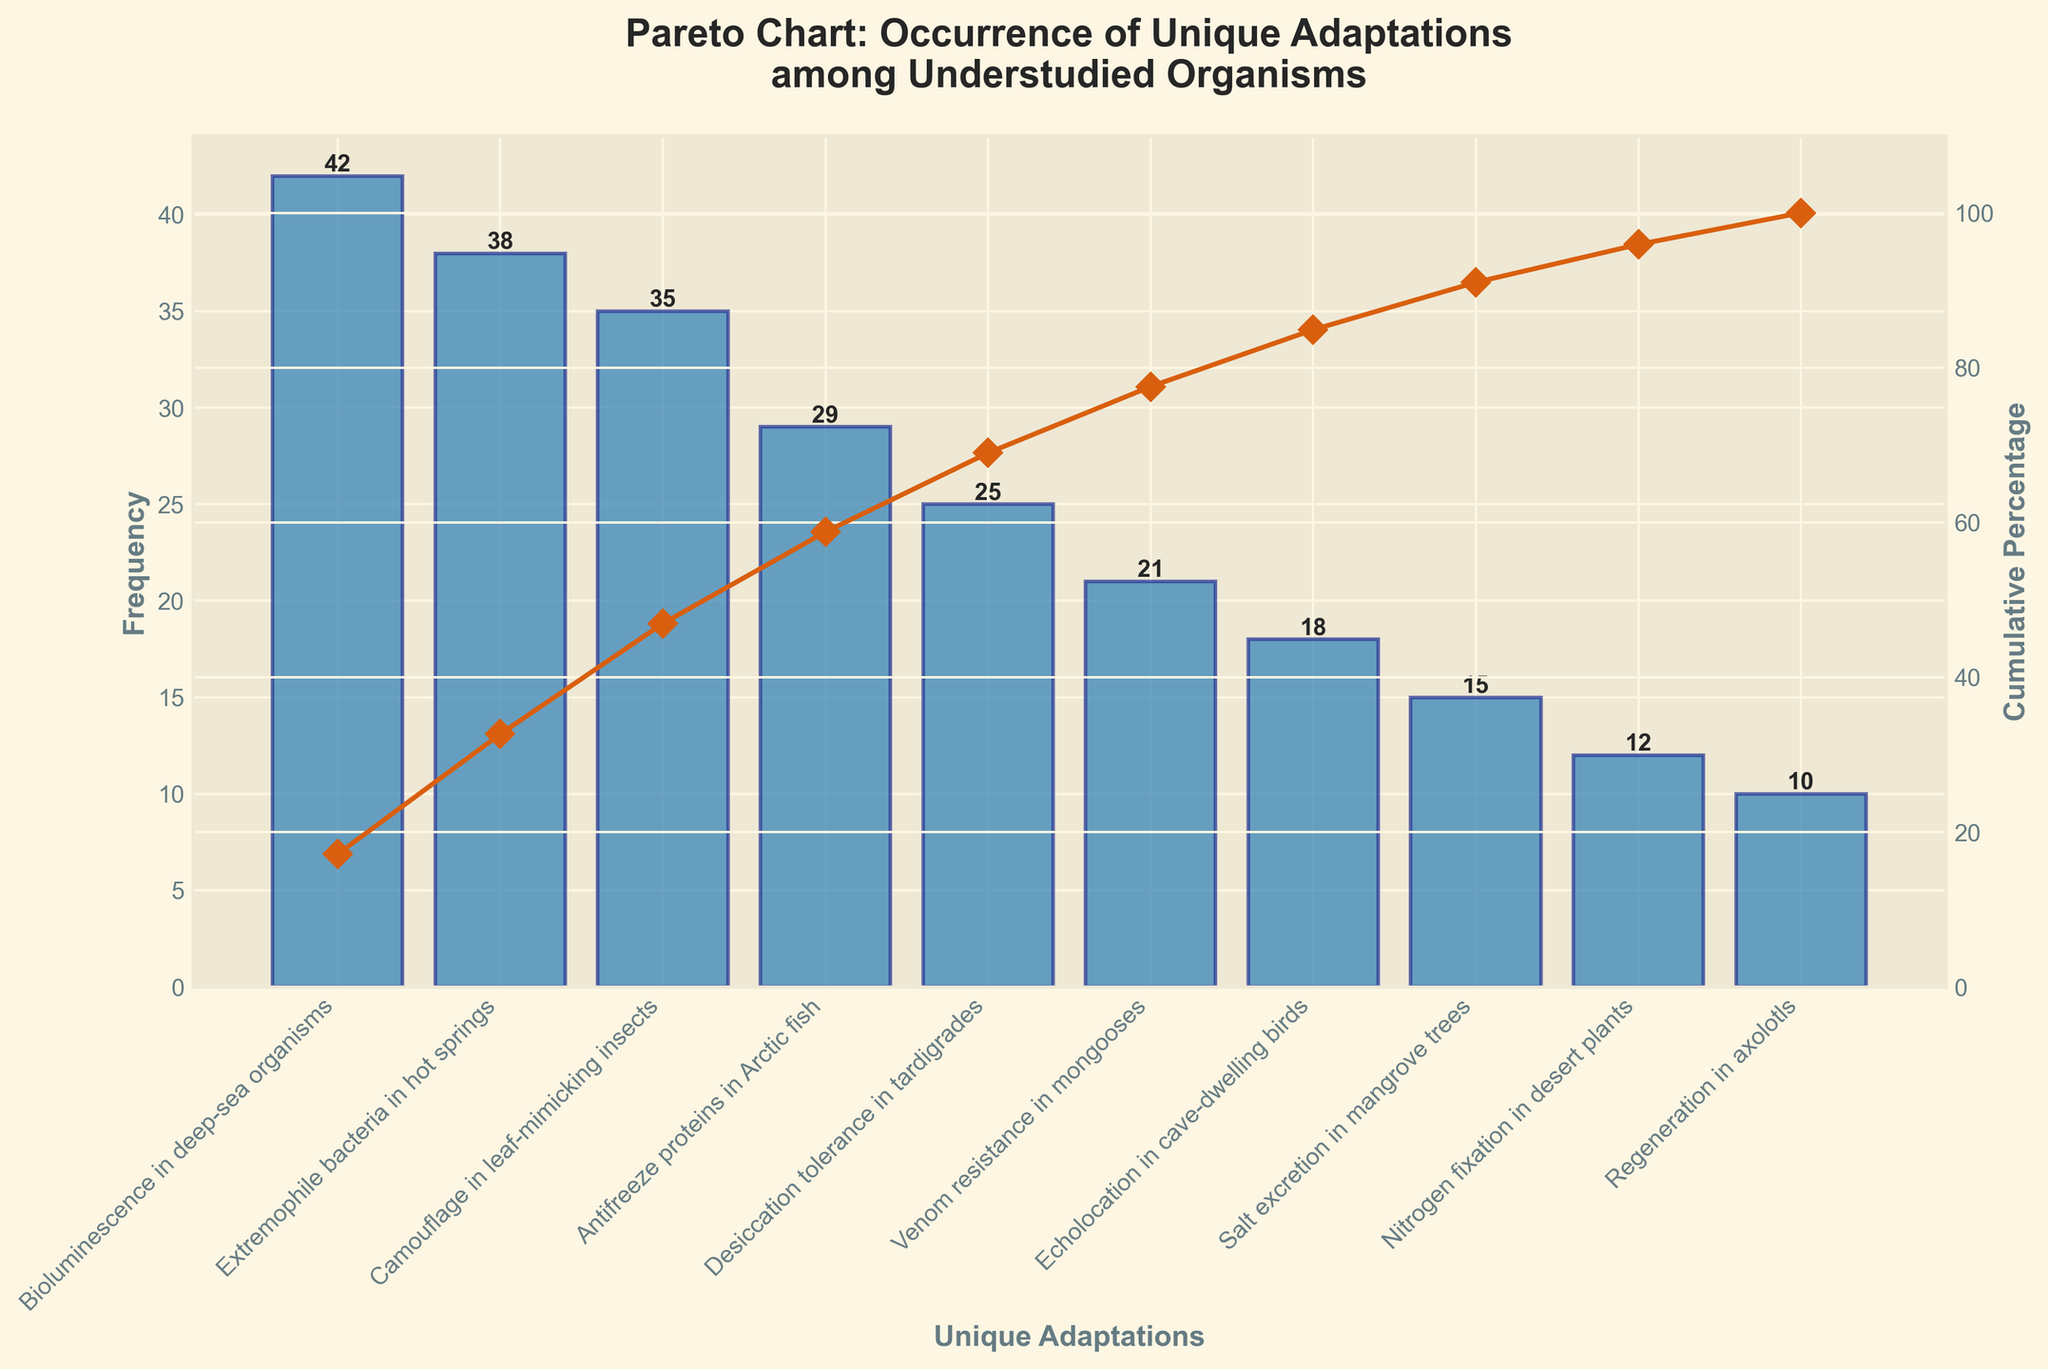How many unique adaptations are shown in the chart? Count all the unique adaptation labels on the x-axis to determine the number.
Answer: 10 What is the adaptation with the highest frequency? Identify the tallest bar on the chart, which corresponds to the adaptation with the highest frequency.
Answer: Bioluminescence in deep-sea organisms Which adaptation has a frequency of 21? Look for the bar labeled with a frequency of 21 and identify the corresponding adaptation label on the x-axis.
Answer: Venom resistance in mongooses What is the cumulative percentage after the top three adaptations? Sum the frequencies of the top three adaptations and divide by the total, then multiply by 100 to get the cumulative percentage. Cumulative percentage after Bioluminescence in deep-sea organisms (42), Extremophile bacteria in hot springs (38), and Camouflage in leaf-mimicking insects (35) is ((42+38+35)/245)*100 = 47.76%.
Answer: 47.76% Compare the frequency of Antifreeze proteins in Arctic fish to Regeneration in axolotls. Which one is higher and by how much? Subtract the frequency of Regeneration in axolotls (10) from Antifreeze proteins in Arctic fish (29). Thus, 29 - 10 = 19.
Answer: Antifreeze proteins in Arctic fish by 19 What cumulative percentage does the Echolocation in cave-dwelling birds adaptation mark? Look at the cumulative percentage value lined up with Echolocation in cave-dwelling birds on the chart.
Answer: 81.63% How many adaptations fall below a 20% cumulative percentage? Identify the x-axis labels whose cumulative percentages sum up to less than 20%. The first two adaptations (Bioluminescence in deep-sea organisms and Extremophile bacteria in hot springs) combined have a cumulative percentage of 16.33%, which is below 20%.
Answer: 2 Which adaptation contributes to reaching a cumulative percentage of 60%? Find the point on the cumulative percentage curve closest to 60% and identify the corresponding adaptation. Camouflage in leaf-mimicking insects pushes the cumulative percentage to 47.76%, and Antifreeze proteins in Arctic fish gets it to 59.18%. Therefore, Antifreeze proteins in Arctic fish is the one contributing to just reaching 60%.
Answer: Antifreeze proteins in Arctic fish Out of the adaptations with a cumulative percentage below 50%, which has the lowest frequency? Review the individual frequencies of adaptations with a cumulative percentage below 50%. Desiccation tolerance in tardigrades has the lowest frequency at 25 among the adaptations falling within this range.
Answer: Desiccation tolerance in tardigrades 